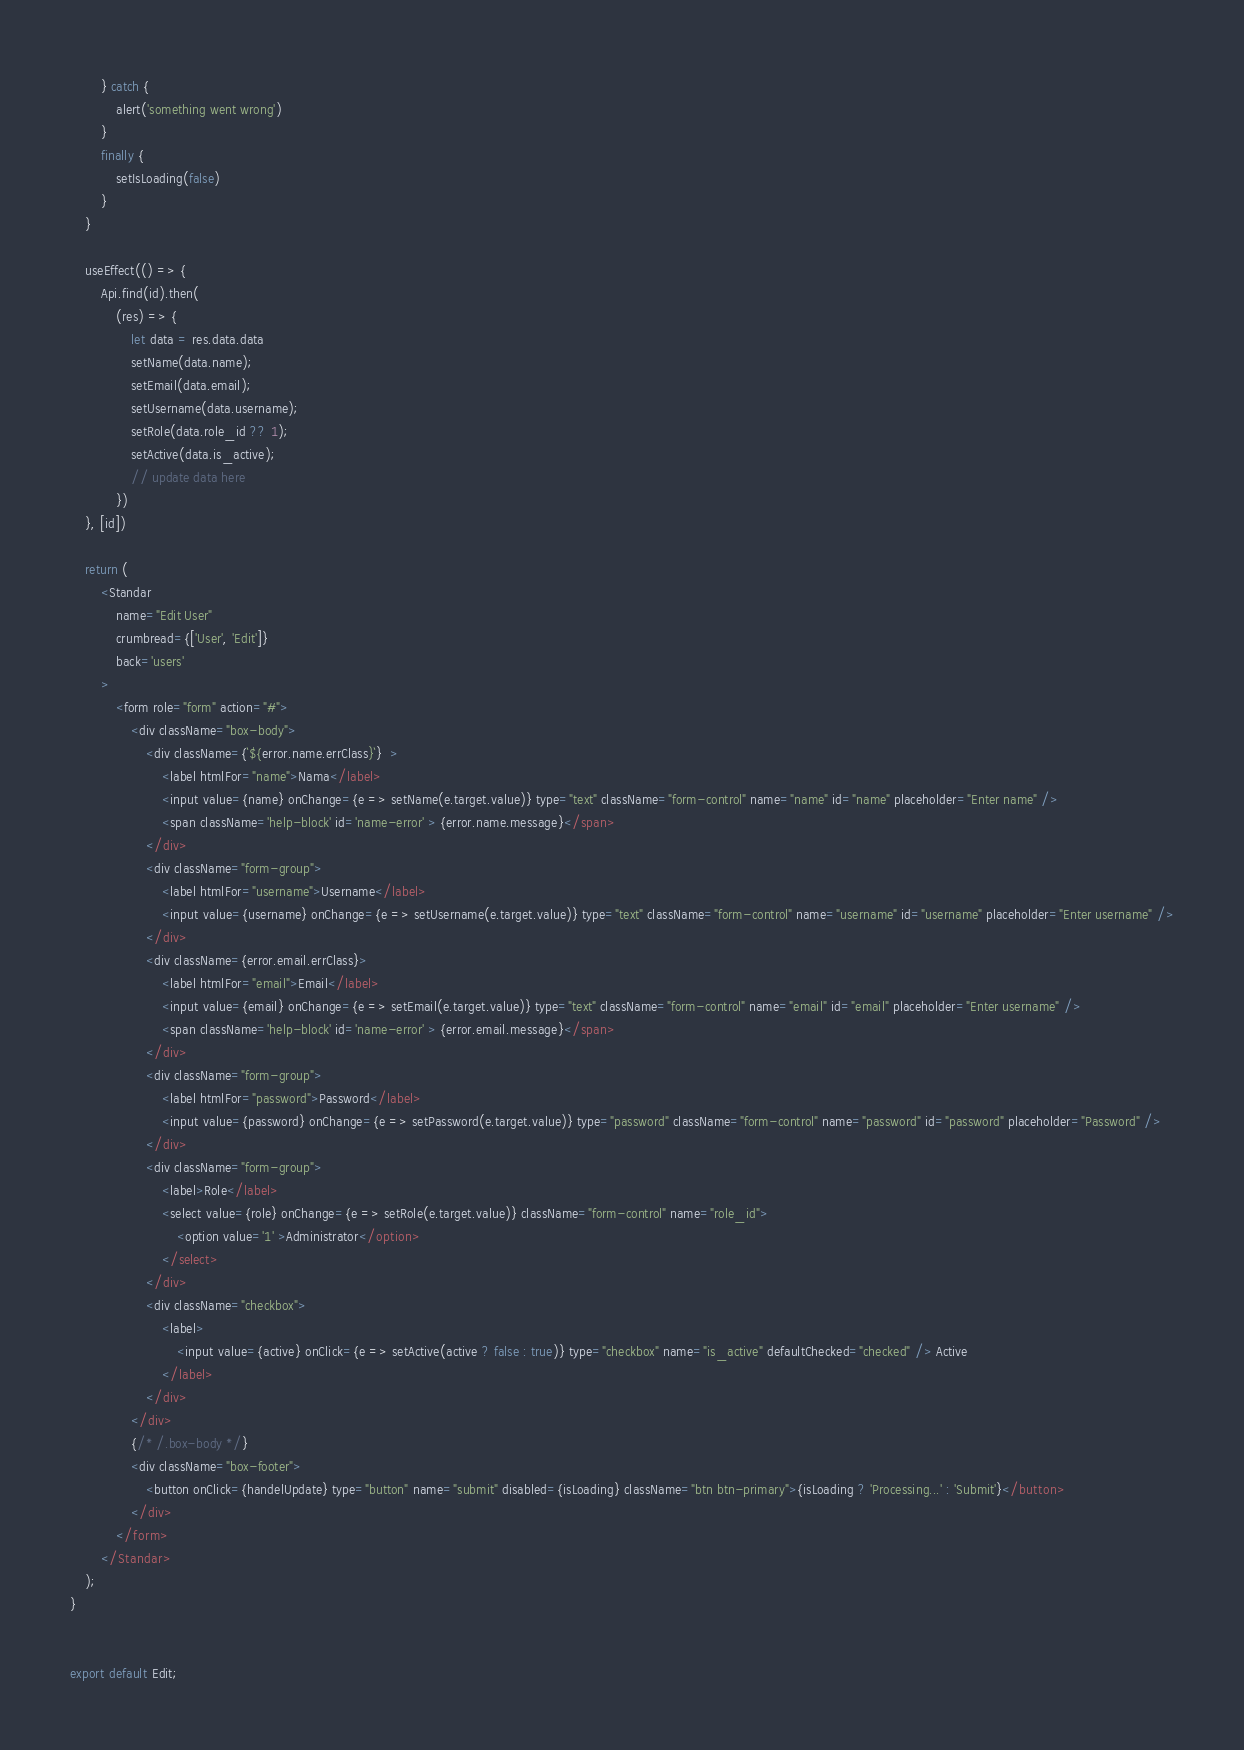Convert code to text. <code><loc_0><loc_0><loc_500><loc_500><_JavaScript_>        } catch {
            alert('something went wrong')
        }
        finally {
            setIsLoading(false)
        }
    }

    useEffect(() => {
        Api.find(id).then(
            (res) => {
                let data = res.data.data
                setName(data.name);
                setEmail(data.email);
                setUsername(data.username);
                setRole(data.role_id ?? 1);
                setActive(data.is_active);
                // update data here
            })
    }, [id])

    return (
        <Standar
            name="Edit User"
            crumbread={['User', 'Edit']}
            back='users'
        >
            <form role="form" action="#">
                <div className="box-body">
                    <div className={`${error.name.errClass}`}  >
                        <label htmlFor="name">Nama</label>
                        <input value={name} onChange={e => setName(e.target.value)} type="text" className="form-control" name="name" id="name" placeholder="Enter name" />
                        <span className='help-block' id='name-error' > {error.name.message}</span>
                    </div>
                    <div className="form-group">
                        <label htmlFor="username">Username</label>
                        <input value={username} onChange={e => setUsername(e.target.value)} type="text" className="form-control" name="username" id="username" placeholder="Enter username" />
                    </div>
                    <div className={error.email.errClass}>
                        <label htmlFor="email">Email</label>
                        <input value={email} onChange={e => setEmail(e.target.value)} type="text" className="form-control" name="email" id="email" placeholder="Enter username" />
                        <span className='help-block' id='name-error' > {error.email.message}</span>
                    </div>
                    <div className="form-group">
                        <label htmlFor="password">Password</label>
                        <input value={password} onChange={e => setPassword(e.target.value)} type="password" className="form-control" name="password" id="password" placeholder="Password" />
                    </div>
                    <div className="form-group">
                        <label>Role</label>
                        <select value={role} onChange={e => setRole(e.target.value)} className="form-control" name="role_id">
                            <option value='1' >Administrator</option>
                        </select>
                    </div>
                    <div className="checkbox">
                        <label>
                            <input value={active} onClick={e => setActive(active ? false : true)} type="checkbox" name="is_active" defaultChecked="checked" /> Active
                        </label>
                    </div>
                </div>
                {/* /.box-body */}
                <div className="box-footer">
                    <button onClick={handelUpdate} type="button" name="submit" disabled={isLoading} className="btn btn-primary">{isLoading ? 'Processing...' : 'Submit'}</button>
                </div>
            </form>
        </Standar>
    );
}


export default Edit;
</code> 